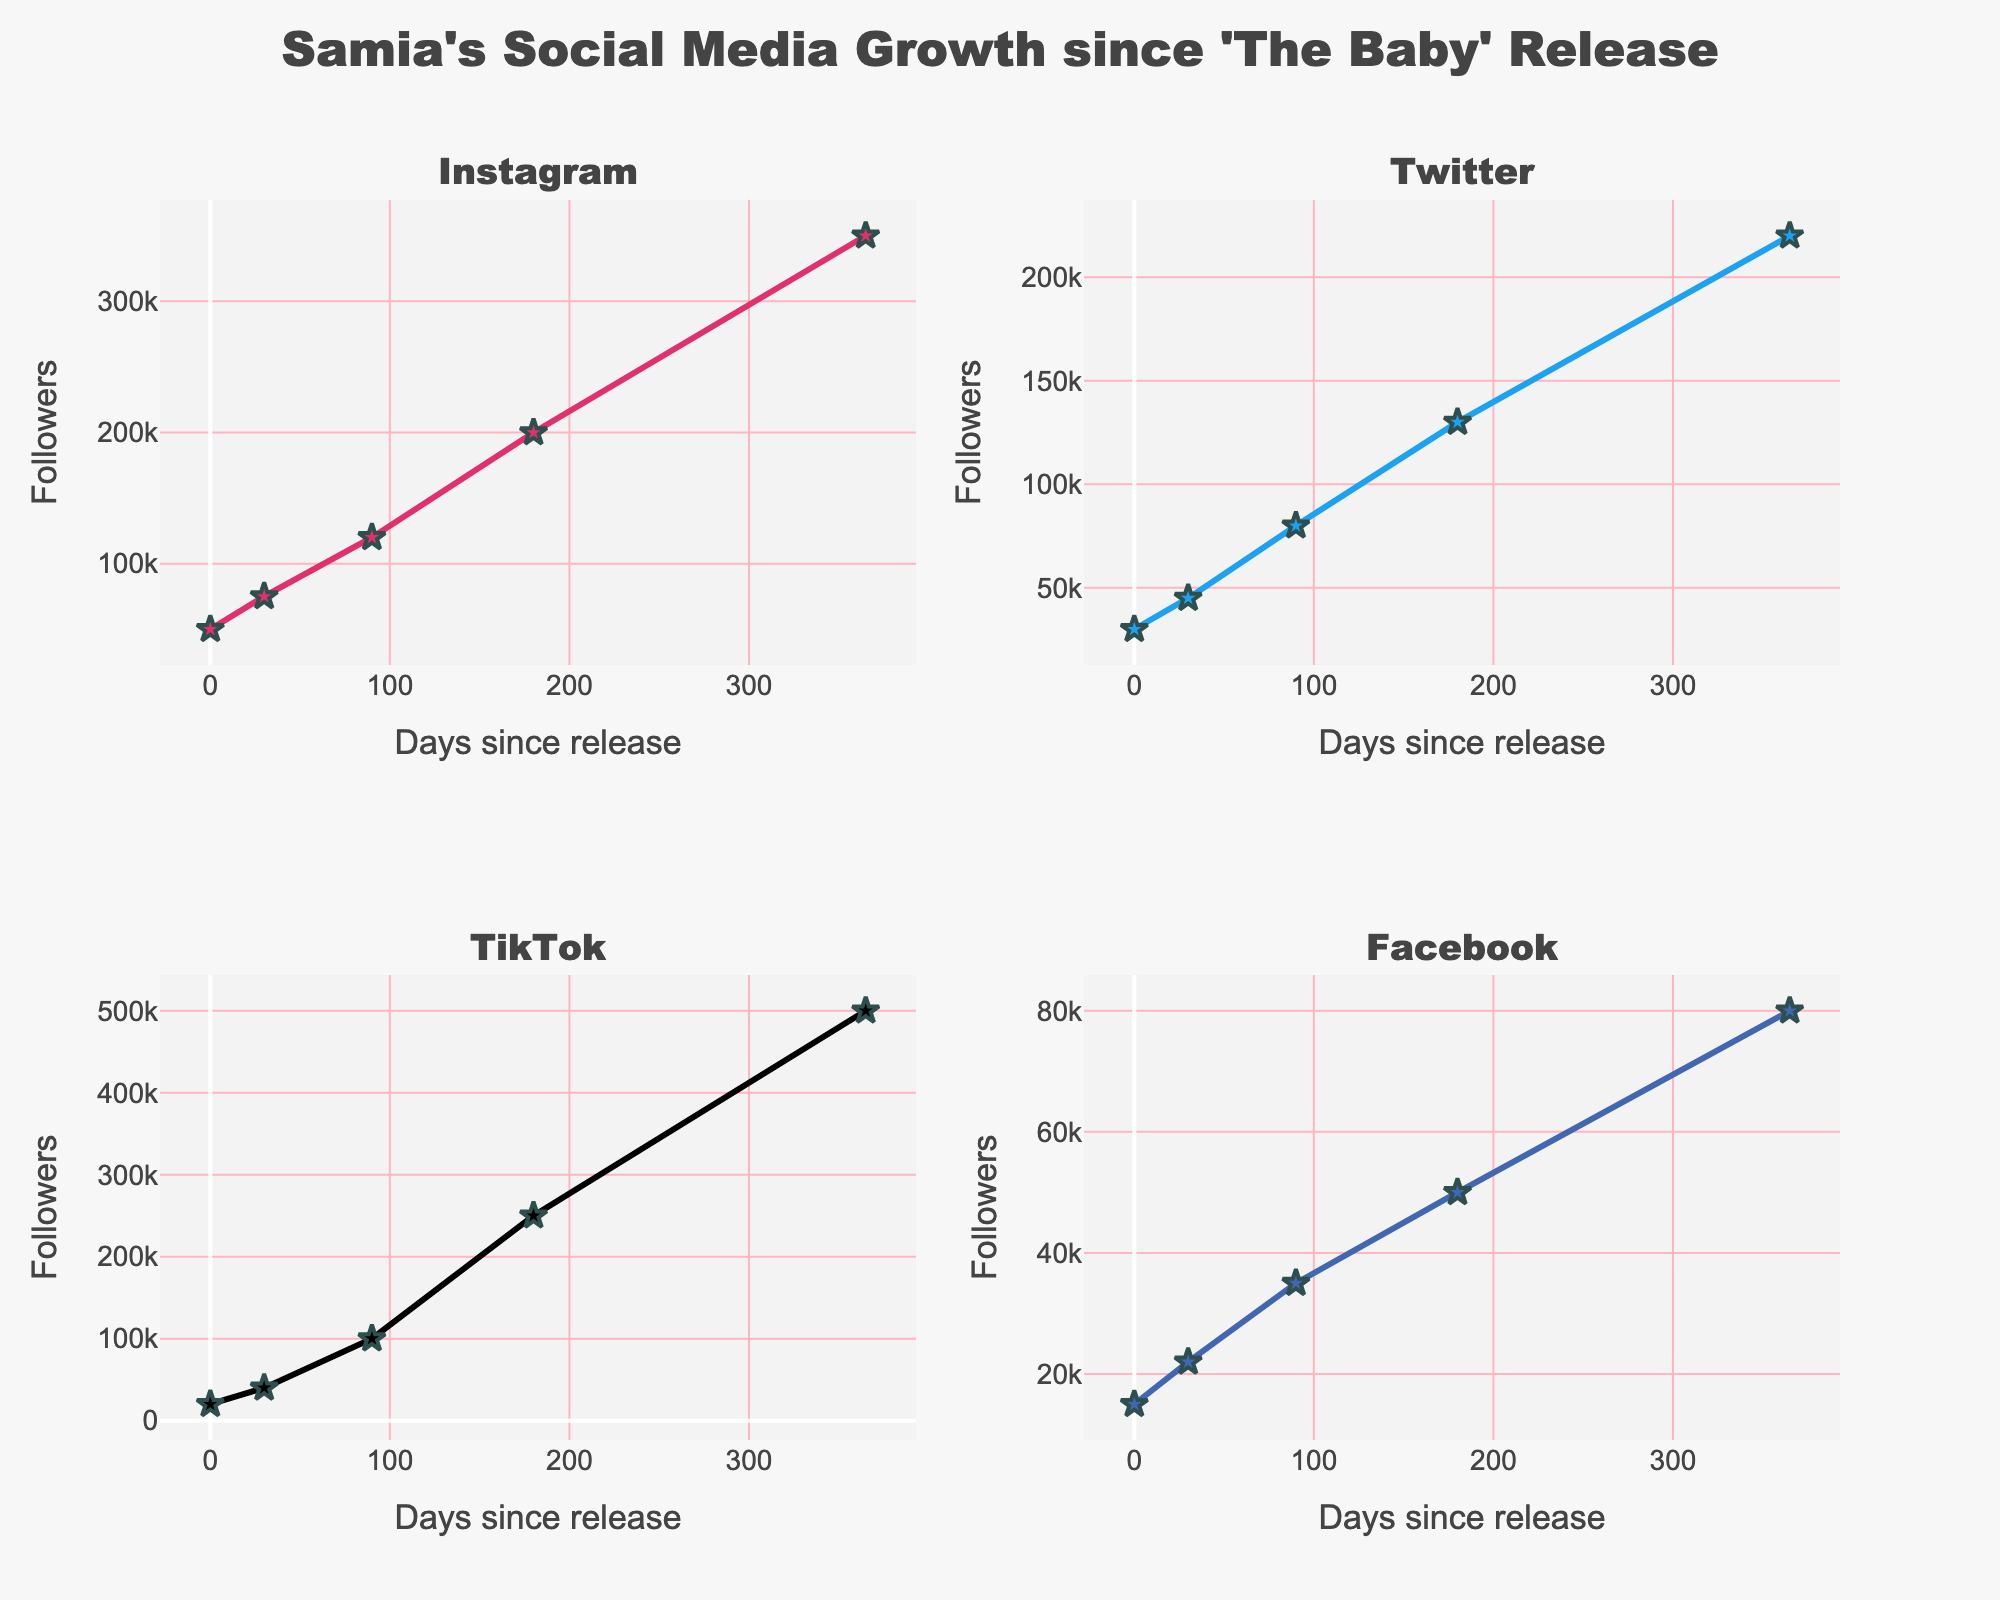Which social media platform saw the highest follower growth on day 365? To find the platform with the highest follower growth on day 365, look at the final data point for each subplot. TikTok has 500,000 followers on day 365, which is the highest among all.
Answer: TikTok How many times greater are TikTok followers compared to Facebook followers on day 90? On day 90, TikTok has 100,000 followers, and Facebook has 35,000 followers. The ratio of TikTok to Facebook followers is 100,000 / 35,000, which simplifies to around 2.86.
Answer: Approximately 2.86 times Which platform had the most rapid initial increase in followers within the first 30 days? To find the most rapid initial increase, compare the difference in followers from day 0 to day 30 for each platform. TikTok grew from 20,000 to 40,000 (an increase of 20,000), which is the highest among all platforms.
Answer: TikTok Between Instagram and Twitter, which platform had more followers on day 180? Compare Instagram’s and Twitter’s follower counts on day 180. Instagram has 200,000 followers while Twitter has 130,000 followers on day 180.
Answer: Instagram What is the total number of followers for Instagram and Twitter combined on day 30? Sum the followers for Instagram and Twitter on day 30. Instagram has 75,000 and Twitter has 45,000, giving a combined total of 75,000 + 45,000 = 120,000.
Answer: 120,000 Which platform exhibited the slowest growth rate overall? To determine the slowest growth rate, look at the overall increase from day 0 to day 365 for each subplot. Facebook grew from 15,000 to 80,000, which is the smallest increase compared to the other platforms.
Answer: Facebook What is the difference in the number of followers between Instagram and TikTok on day 365? On day 365, TikTok has 500,000 followers and Instagram has 350,000 followers. The difference is 500,000 - 350,000 = 150,000 followers.
Answer: 150,000 Did any platform experience a decrease in followers at any point? Inspect the trend lines of all subplots. All platforms show increasing trends, with no decreases at any point.
Answer: No Among all platforms, which one had the highest follower count on day 0? To find the highest follower count on day 0, compare the initial data points for each subplot. Instagram has 50,000 followers on day 0, the highest among all platforms.
Answer: Instagram 